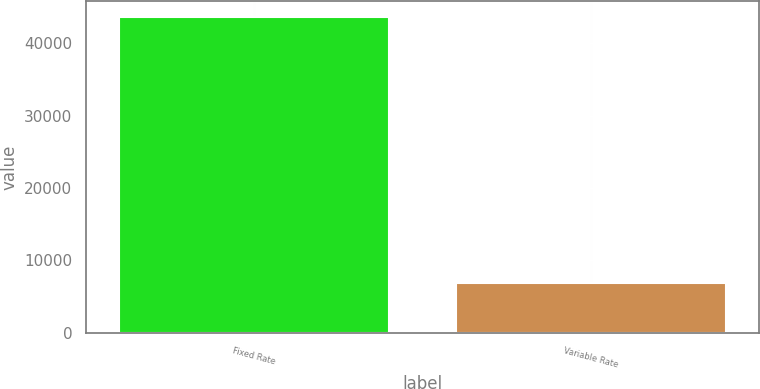<chart> <loc_0><loc_0><loc_500><loc_500><bar_chart><fcel>Fixed Rate<fcel>Variable Rate<nl><fcel>43673<fcel>6870<nl></chart> 